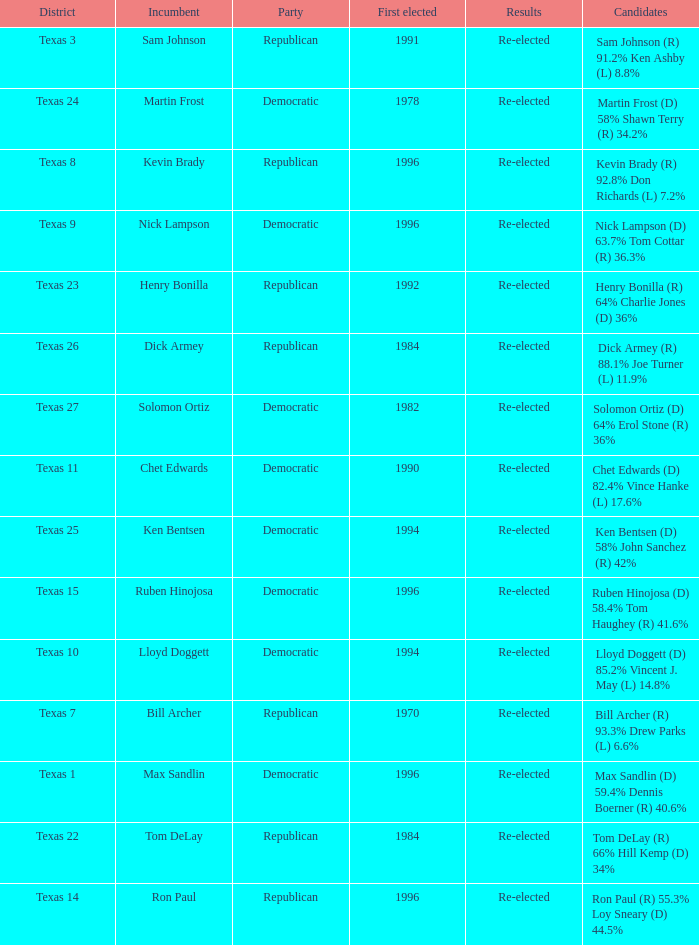How many times did incumbent ruben hinojosa get elected? 1.0. 